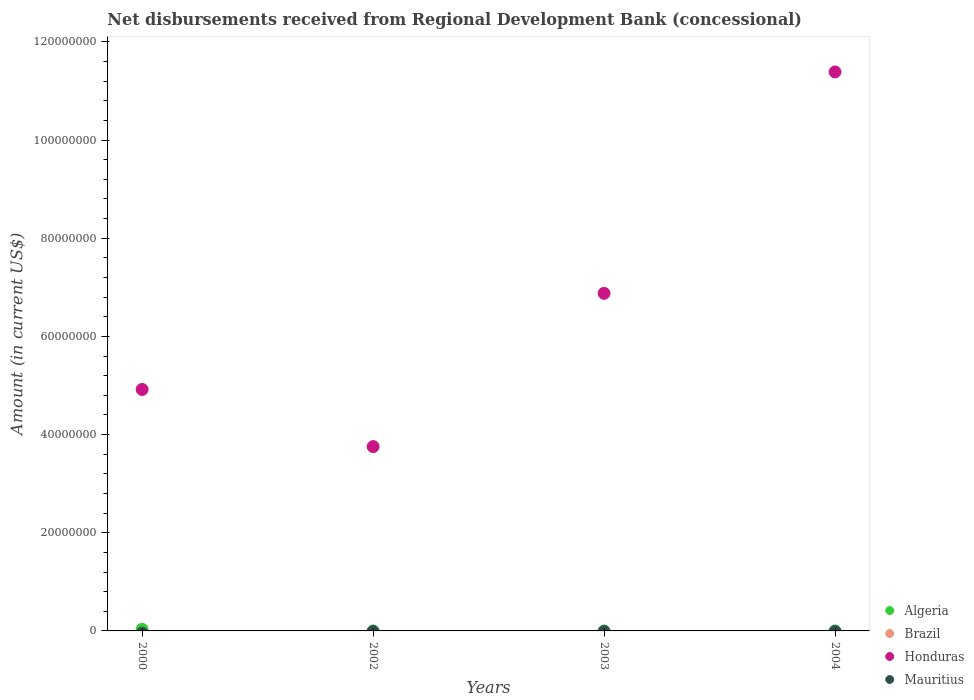How many different coloured dotlines are there?
Offer a terse response. 2. Across all years, what is the maximum amount of disbursements received from Regional Development Bank in Algeria?
Keep it short and to the point. 3.30e+05. What is the total amount of disbursements received from Regional Development Bank in Honduras in the graph?
Keep it short and to the point. 2.69e+08. What is the difference between the amount of disbursements received from Regional Development Bank in Honduras in 2000 and that in 2002?
Provide a short and direct response. 1.16e+07. What is the difference between the amount of disbursements received from Regional Development Bank in Algeria in 2004 and the amount of disbursements received from Regional Development Bank in Honduras in 2003?
Provide a short and direct response. -6.88e+07. What is the average amount of disbursements received from Regional Development Bank in Algeria per year?
Offer a very short reply. 8.25e+04. In how many years, is the amount of disbursements received from Regional Development Bank in Mauritius greater than 60000000 US$?
Your answer should be very brief. 0. What is the ratio of the amount of disbursements received from Regional Development Bank in Honduras in 2002 to that in 2004?
Provide a succinct answer. 0.33. Is the amount of disbursements received from Regional Development Bank in Honduras in 2000 less than that in 2004?
Keep it short and to the point. Yes. What is the difference between the highest and the second highest amount of disbursements received from Regional Development Bank in Honduras?
Your answer should be compact. 4.51e+07. What is the difference between the highest and the lowest amount of disbursements received from Regional Development Bank in Algeria?
Provide a short and direct response. 3.30e+05. In how many years, is the amount of disbursements received from Regional Development Bank in Honduras greater than the average amount of disbursements received from Regional Development Bank in Honduras taken over all years?
Your answer should be compact. 2. Is the sum of the amount of disbursements received from Regional Development Bank in Honduras in 2000 and 2002 greater than the maximum amount of disbursements received from Regional Development Bank in Algeria across all years?
Offer a very short reply. Yes. Is it the case that in every year, the sum of the amount of disbursements received from Regional Development Bank in Honduras and amount of disbursements received from Regional Development Bank in Brazil  is greater than the sum of amount of disbursements received from Regional Development Bank in Mauritius and amount of disbursements received from Regional Development Bank in Algeria?
Your answer should be very brief. No. Is it the case that in every year, the sum of the amount of disbursements received from Regional Development Bank in Algeria and amount of disbursements received from Regional Development Bank in Brazil  is greater than the amount of disbursements received from Regional Development Bank in Mauritius?
Keep it short and to the point. No. Is the amount of disbursements received from Regional Development Bank in Mauritius strictly greater than the amount of disbursements received from Regional Development Bank in Brazil over the years?
Offer a terse response. Yes. How many dotlines are there?
Your answer should be compact. 2. How many years are there in the graph?
Provide a succinct answer. 4. What is the difference between two consecutive major ticks on the Y-axis?
Offer a very short reply. 2.00e+07. Does the graph contain grids?
Offer a terse response. No. Where does the legend appear in the graph?
Keep it short and to the point. Bottom right. How many legend labels are there?
Offer a very short reply. 4. How are the legend labels stacked?
Make the answer very short. Vertical. What is the title of the graph?
Provide a short and direct response. Net disbursements received from Regional Development Bank (concessional). Does "Dominica" appear as one of the legend labels in the graph?
Ensure brevity in your answer.  No. What is the label or title of the Y-axis?
Provide a short and direct response. Amount (in current US$). What is the Amount (in current US$) of Honduras in 2000?
Your response must be concise. 4.92e+07. What is the Amount (in current US$) in Honduras in 2002?
Offer a terse response. 3.75e+07. What is the Amount (in current US$) in Brazil in 2003?
Provide a succinct answer. 0. What is the Amount (in current US$) in Honduras in 2003?
Offer a terse response. 6.88e+07. What is the Amount (in current US$) in Honduras in 2004?
Your response must be concise. 1.14e+08. What is the Amount (in current US$) of Mauritius in 2004?
Your answer should be very brief. 0. Across all years, what is the maximum Amount (in current US$) of Algeria?
Keep it short and to the point. 3.30e+05. Across all years, what is the maximum Amount (in current US$) in Honduras?
Your answer should be compact. 1.14e+08. Across all years, what is the minimum Amount (in current US$) in Algeria?
Ensure brevity in your answer.  0. Across all years, what is the minimum Amount (in current US$) in Honduras?
Make the answer very short. 3.75e+07. What is the total Amount (in current US$) in Algeria in the graph?
Offer a terse response. 3.30e+05. What is the total Amount (in current US$) in Brazil in the graph?
Ensure brevity in your answer.  0. What is the total Amount (in current US$) of Honduras in the graph?
Ensure brevity in your answer.  2.69e+08. What is the total Amount (in current US$) of Mauritius in the graph?
Provide a short and direct response. 0. What is the difference between the Amount (in current US$) of Honduras in 2000 and that in 2002?
Your answer should be very brief. 1.16e+07. What is the difference between the Amount (in current US$) of Honduras in 2000 and that in 2003?
Keep it short and to the point. -1.96e+07. What is the difference between the Amount (in current US$) in Honduras in 2000 and that in 2004?
Give a very brief answer. -6.47e+07. What is the difference between the Amount (in current US$) of Honduras in 2002 and that in 2003?
Make the answer very short. -3.12e+07. What is the difference between the Amount (in current US$) in Honduras in 2002 and that in 2004?
Offer a very short reply. -7.63e+07. What is the difference between the Amount (in current US$) of Honduras in 2003 and that in 2004?
Give a very brief answer. -4.51e+07. What is the difference between the Amount (in current US$) in Algeria in 2000 and the Amount (in current US$) in Honduras in 2002?
Keep it short and to the point. -3.72e+07. What is the difference between the Amount (in current US$) in Algeria in 2000 and the Amount (in current US$) in Honduras in 2003?
Ensure brevity in your answer.  -6.84e+07. What is the difference between the Amount (in current US$) of Algeria in 2000 and the Amount (in current US$) of Honduras in 2004?
Your answer should be very brief. -1.14e+08. What is the average Amount (in current US$) in Algeria per year?
Your response must be concise. 8.25e+04. What is the average Amount (in current US$) of Brazil per year?
Your response must be concise. 0. What is the average Amount (in current US$) in Honduras per year?
Your answer should be very brief. 6.73e+07. What is the average Amount (in current US$) of Mauritius per year?
Offer a terse response. 0. In the year 2000, what is the difference between the Amount (in current US$) in Algeria and Amount (in current US$) in Honduras?
Your response must be concise. -4.89e+07. What is the ratio of the Amount (in current US$) of Honduras in 2000 to that in 2002?
Offer a terse response. 1.31. What is the ratio of the Amount (in current US$) in Honduras in 2000 to that in 2003?
Provide a short and direct response. 0.72. What is the ratio of the Amount (in current US$) in Honduras in 2000 to that in 2004?
Provide a short and direct response. 0.43. What is the ratio of the Amount (in current US$) in Honduras in 2002 to that in 2003?
Provide a short and direct response. 0.55. What is the ratio of the Amount (in current US$) of Honduras in 2002 to that in 2004?
Offer a very short reply. 0.33. What is the ratio of the Amount (in current US$) in Honduras in 2003 to that in 2004?
Ensure brevity in your answer.  0.6. What is the difference between the highest and the second highest Amount (in current US$) in Honduras?
Offer a very short reply. 4.51e+07. What is the difference between the highest and the lowest Amount (in current US$) in Algeria?
Make the answer very short. 3.30e+05. What is the difference between the highest and the lowest Amount (in current US$) in Honduras?
Provide a succinct answer. 7.63e+07. 